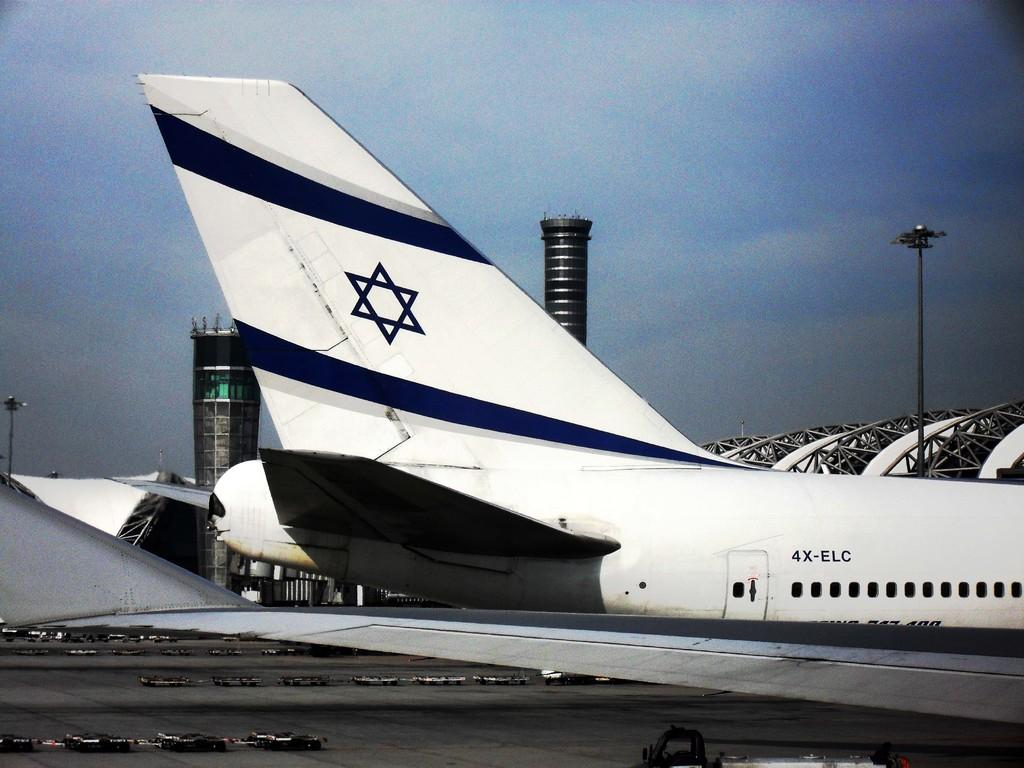What is the main subject of the image? The main subject of the image is an airplane. What colors are used to paint the airplane? The airplane is white and blue in color. What feature can be seen on the airplane? The airplane has windows. What else can be seen in the image besides the airplane? There are light poles and objects on the ground visible in the image. What is the color of the sky in the image? The sky is white and blue in color. How many eyes does the farmer have in the image? There is no farmer present in the image, so it is not possible to determine the number of eyes they might have. 